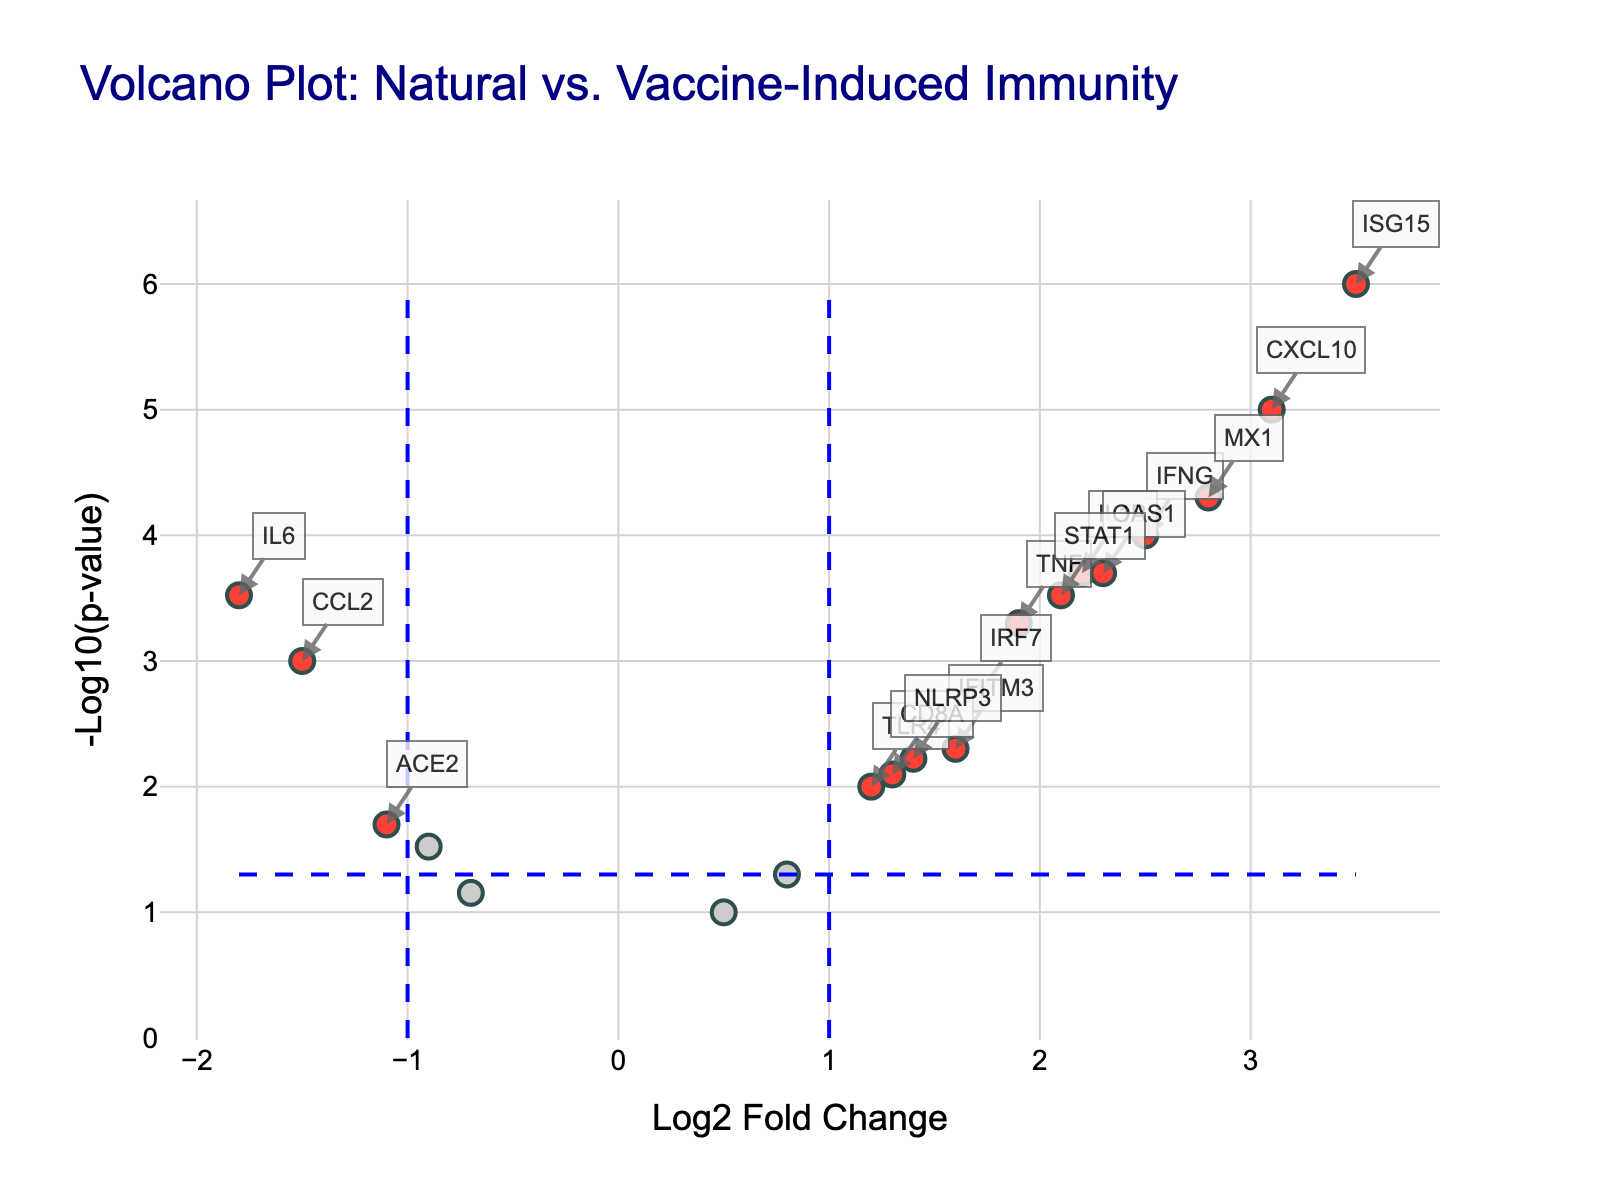What is the title of the plot? The title is displayed at the top of the plot and helps to quickly identify the topic of analysis.
Answer: Volcano Plot: Natural vs. Vaccine-Induced Immunity Which axis represents the Log2 Fold Change? The axis labels identify which data features are represented by the axes. By reading these labels, the x-axis is for Log2 Fold Change.
Answer: x-axis How many genes are labeled as significant (colored in red)? The custom colors distinctively separate significant genes (colored in red) from others (colored in grey). By counting the red points, there are 11 significant genes.
Answer: 11 Which gene has the highest -Log10(p-value)? The plot annotates significant genes with their names and their positions. The highest -Log10(p-value) is the furthest point along the y-axis. By looking at the topmost point, the gene is ISG15.
Answer: ISG15 What is the Log2 Fold Change and p-value of the gene IFNG? The hover information provides exact details of each point, but we can also read it off the plot. The gene IFNG at (2.5, 4) means a Log2 Fold Change of 2.5 and a p-value of 0.0001.
Answer: Log2 Fold Change: 2.5, p-value: 0.0001 What is the significance threshold applied on Log2 Fold Change? The threshold lines determine the significance levels. From the plot, the Log2 Fold Change thresholds are set at ±1.
Answer: ±1 Which gene has a Log2 Fold Change below -1 and is considered significant? By focusing on points to the left of the -1 threshold and colored in red, the significant gene with Log2 Fold Change below -1 is IL6.
Answer: IL6 What is the -Log10(p-value) for the significance threshold of p-value = 0.05? The horizontal threshold line marks this point on the y-axis. Converting the significance threshold (0.05) to -Log10(p-value) is -log10(0.05) which is approximately 1.3.
Answer: 1.3 Compare CXCL10 and STAT1: which gene has a higher Log2 Fold Change, and which has a smaller p-value? Locate CXCL10 and STAT1 on the plot and compare their coordinates. CXCL10 (3.1, 5) has higher Log2 Fold Change than STAT1 (2.1, 3.5) and a smaller p-value.
Answer: CXCL10 for both If the threshold for significance would change to p < 0.01, how many genes would remain significant? To find this, count the red points above the line corresponding to -log10(0.01) ≈ 2. By inspecting, seven genes have p-values smaller than 0.01 and remain significant.
Answer: 7 